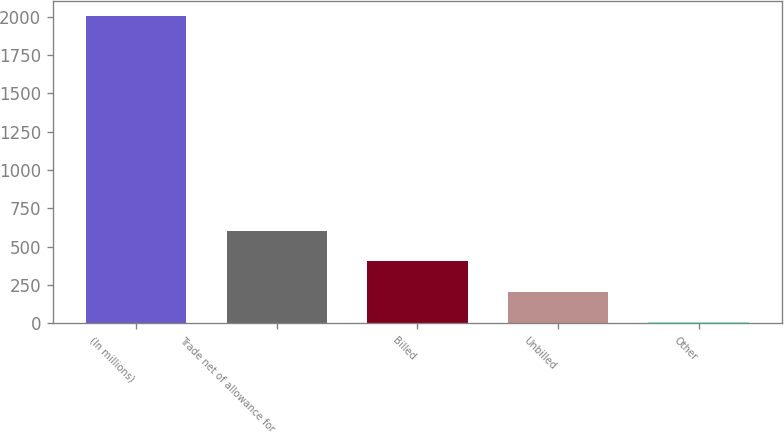Convert chart. <chart><loc_0><loc_0><loc_500><loc_500><bar_chart><fcel>(In millions)<fcel>Trade net of allowance for<fcel>Billed<fcel>Unbilled<fcel>Other<nl><fcel>2003<fcel>605.1<fcel>405.4<fcel>205.7<fcel>6<nl></chart> 